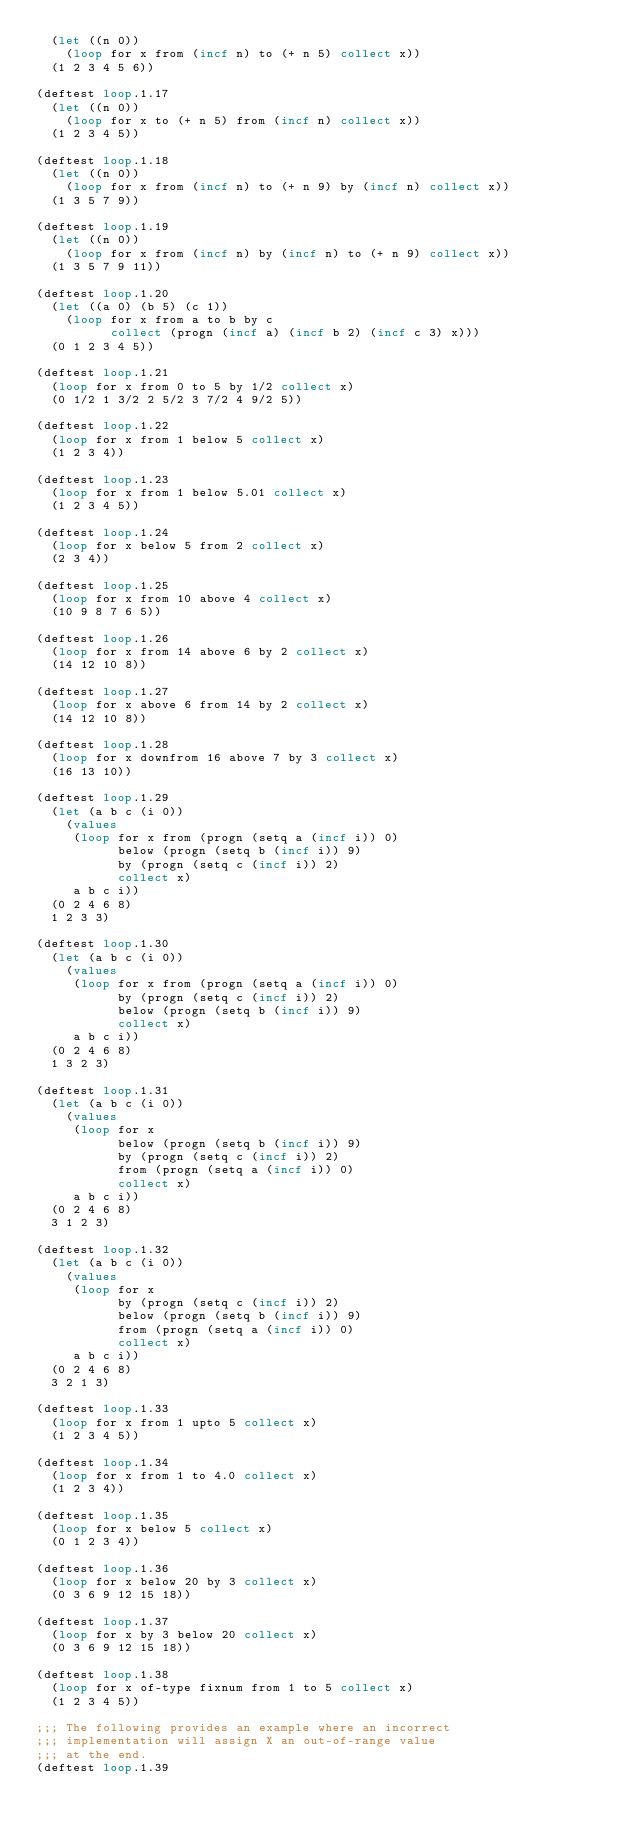Convert code to text. <code><loc_0><loc_0><loc_500><loc_500><_Lisp_>  (let ((n 0))
    (loop for x from (incf n) to (+ n 5) collect x))
  (1 2 3 4 5 6))

(deftest loop.1.17
  (let ((n 0))
    (loop for x to (+ n 5) from (incf n) collect x))
  (1 2 3 4 5))

(deftest loop.1.18
  (let ((n 0))
    (loop for x from (incf n) to (+ n 9) by (incf n) collect x))
  (1 3 5 7 9))

(deftest loop.1.19
  (let ((n 0))
    (loop for x from (incf n) by (incf n) to (+ n 9) collect x))
  (1 3 5 7 9 11))

(deftest loop.1.20
  (let ((a 0) (b 5) (c 1))
    (loop for x from a to b by c
          collect (progn (incf a) (incf b 2) (incf c 3) x)))
  (0 1 2 3 4 5))

(deftest loop.1.21
  (loop for x from 0 to 5 by 1/2 collect x)
  (0 1/2 1 3/2 2 5/2 3 7/2 4 9/2 5))

(deftest loop.1.22
  (loop for x from 1 below 5 collect x)
  (1 2 3 4))

(deftest loop.1.23
  (loop for x from 1 below 5.01 collect x)
  (1 2 3 4 5))

(deftest loop.1.24
  (loop for x below 5 from 2 collect x)
  (2 3 4))

(deftest loop.1.25
  (loop for x from 10 above 4 collect x)
  (10 9 8 7 6 5))

(deftest loop.1.26
  (loop for x from 14 above 6 by 2 collect x)
  (14 12 10 8))

(deftest loop.1.27
  (loop for x above 6 from 14 by 2 collect x)
  (14 12 10 8))

(deftest loop.1.28
  (loop for x downfrom 16 above 7 by 3 collect x)
  (16 13 10))

(deftest loop.1.29
  (let (a b c (i 0))
    (values
     (loop for x from (progn (setq a (incf i)) 0)
           below (progn (setq b (incf i)) 9)
           by (progn (setq c (incf i)) 2)
           collect x)
     a b c i))
  (0 2 4 6 8)
  1 2 3 3)

(deftest loop.1.30
  (let (a b c (i 0))
    (values
     (loop for x from (progn (setq a (incf i)) 0)
           by (progn (setq c (incf i)) 2)
           below (progn (setq b (incf i)) 9)
           collect x)
     a b c i))
  (0 2 4 6 8)
  1 3 2 3)

(deftest loop.1.31
  (let (a b c (i 0))
    (values
     (loop for x
           below (progn (setq b (incf i)) 9)
           by (progn (setq c (incf i)) 2)
           from (progn (setq a (incf i)) 0)
           collect x)
     a b c i))
  (0 2 4 6 8)
  3 1 2 3)

(deftest loop.1.32
  (let (a b c (i 0))
    (values
     (loop for x
           by (progn (setq c (incf i)) 2)
           below (progn (setq b (incf i)) 9)
           from (progn (setq a (incf i)) 0)
           collect x)
     a b c i))
  (0 2 4 6 8)
  3 2 1 3)

(deftest loop.1.33
  (loop for x from 1 upto 5 collect x)
  (1 2 3 4 5))

(deftest loop.1.34
  (loop for x from 1 to 4.0 collect x)
  (1 2 3 4))

(deftest loop.1.35
  (loop for x below 5 collect x)
  (0 1 2 3 4))

(deftest loop.1.36
  (loop for x below 20 by 3 collect x)
  (0 3 6 9 12 15 18))

(deftest loop.1.37
  (loop for x by 3 below 20 collect x)
  (0 3 6 9 12 15 18))

(deftest loop.1.38
  (loop for x of-type fixnum from 1 to 5 collect x)
  (1 2 3 4 5))

;;; The following provides an example where an incorrect
;;; implementation will assign X an out-of-range value
;;; at the end.
(deftest loop.1.39</code> 